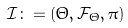Convert formula to latex. <formula><loc_0><loc_0><loc_500><loc_500>\mathcal { I } \colon = ( \Theta , \mathcal { F } _ { \Theta } , \pi )</formula> 